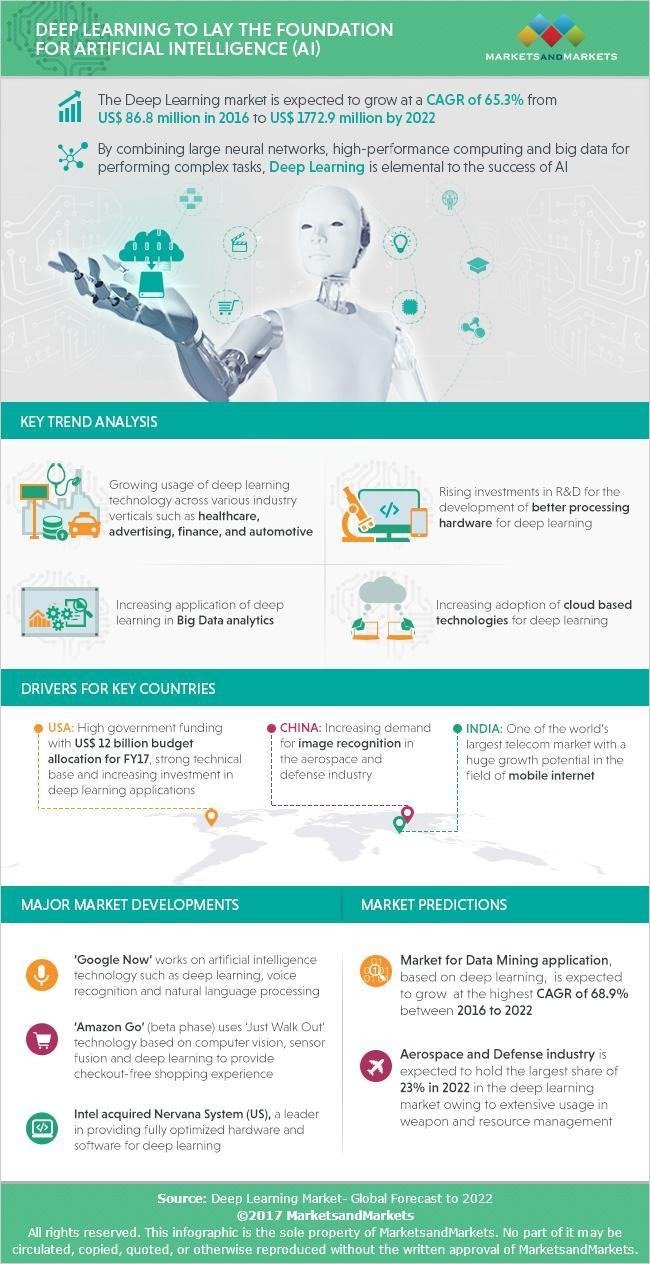How much the Deep Learning Market has grown from the year 2016 to 2022 in US Dollars?
Answer the question with a short phrase. 1,686.1 